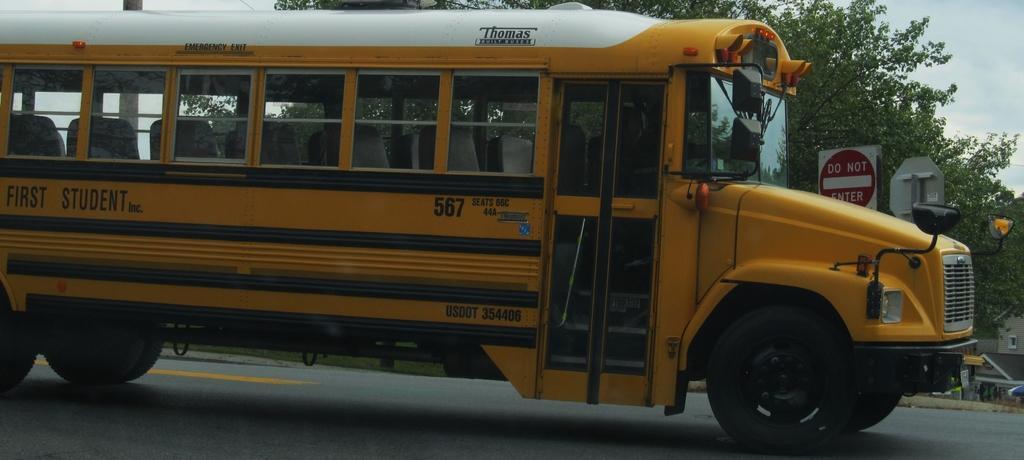Please provide a concise description of this image. In this picture there is a bus on the road and there is text on the bus. At the back there are trees and there is a building and there is a board on the pole and there is text on the board. At the top there is sky and there are clouds. At the bottom there is a road and there is grass. 